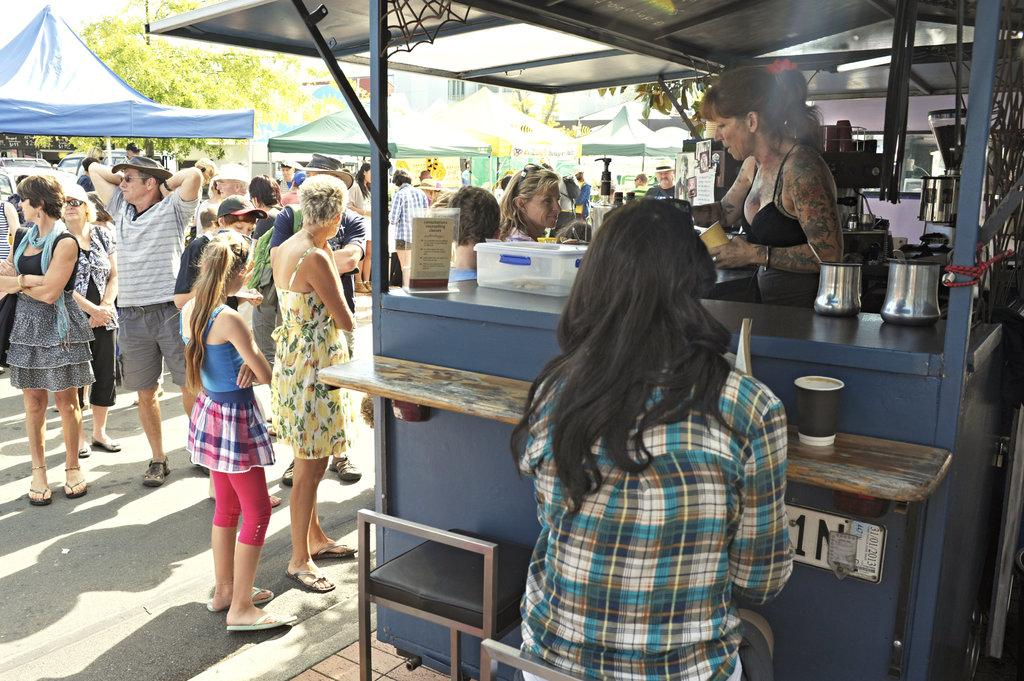What is happening on the road in the image? There are many people standing on the road. What type of establishments can be seen on either side of the road? There are stores on either side of the road. What is covering the road in the image? There are tents above the road. What can be seen in the distance in the image? There are trees visible in the background. How many horses are visible in the image? There are no horses present in the image. What type of ice can be seen melting on the tongue of one of the people in the image? There is no ice or tongue visible in the image. 